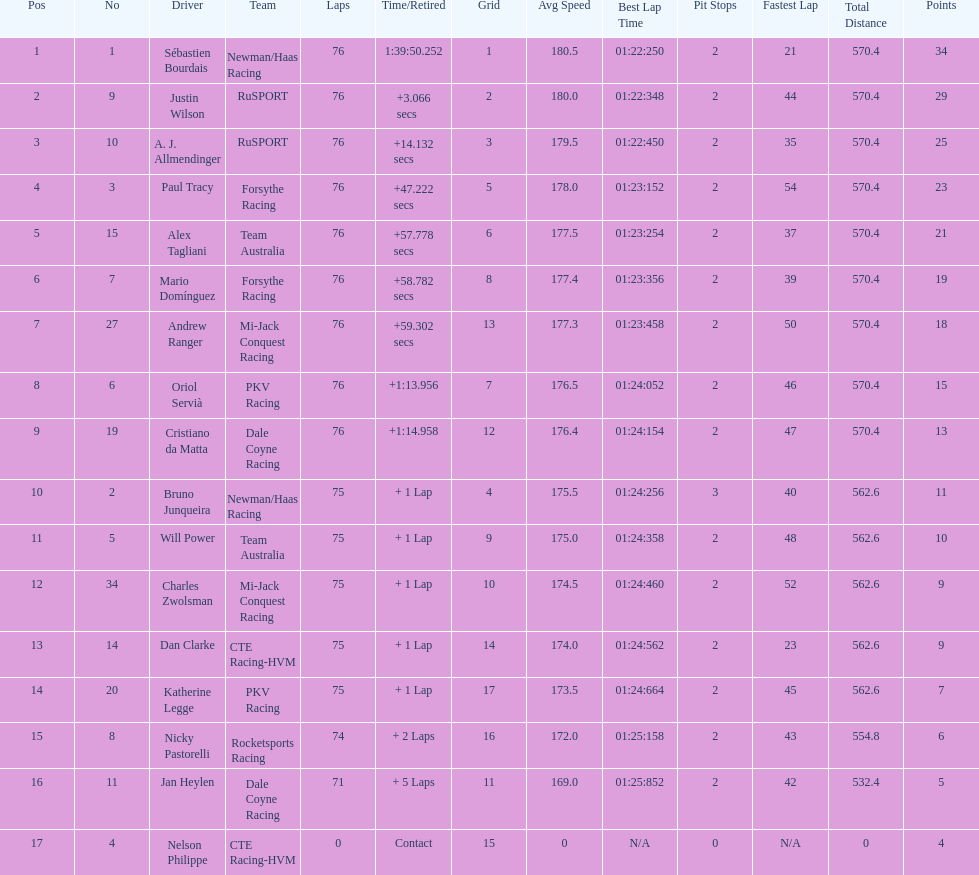How many drivers were competing for brazil? 2. 